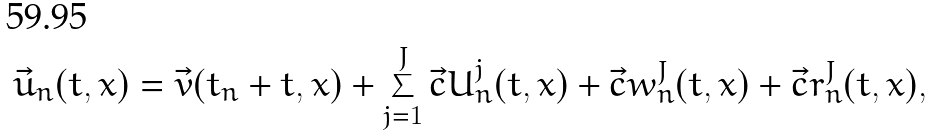Convert formula to latex. <formula><loc_0><loc_0><loc_500><loc_500>\vec { u } _ { n } ( t , x ) = \vec { v } ( t _ { n } + t , x ) + \sum _ { j = 1 } ^ { J } \vec { c } { U } _ { n } ^ { j } ( t , x ) + \vec { c } { w } _ { n } ^ { J } ( t , x ) + \vec { c } { r } _ { n } ^ { J } ( t , x ) ,</formula> 